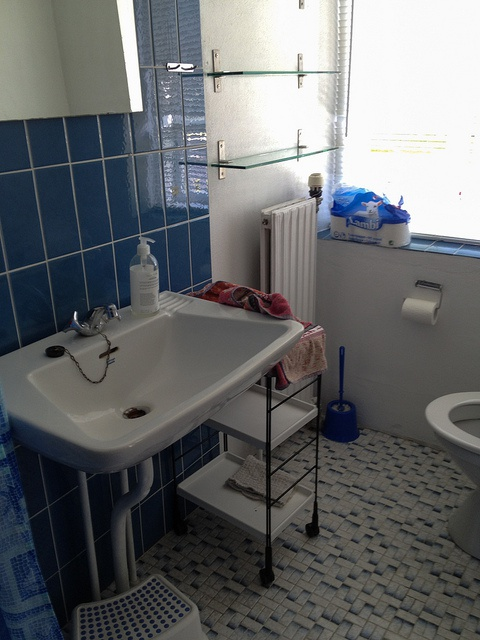Describe the objects in this image and their specific colors. I can see sink in darkgray, gray, and black tones, toilet in darkgray, black, and gray tones, and bottle in darkgray, gray, navy, and darkblue tones in this image. 